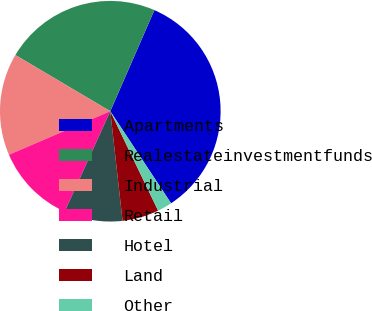<chart> <loc_0><loc_0><loc_500><loc_500><pie_chart><fcel>Apartments<fcel>Realestateinvestmentfunds<fcel>Industrial<fcel>Retail<fcel>Hotel<fcel>Land<fcel>Other<nl><fcel>34.17%<fcel>23.04%<fcel>14.96%<fcel>11.76%<fcel>8.56%<fcel>5.36%<fcel>2.15%<nl></chart> 